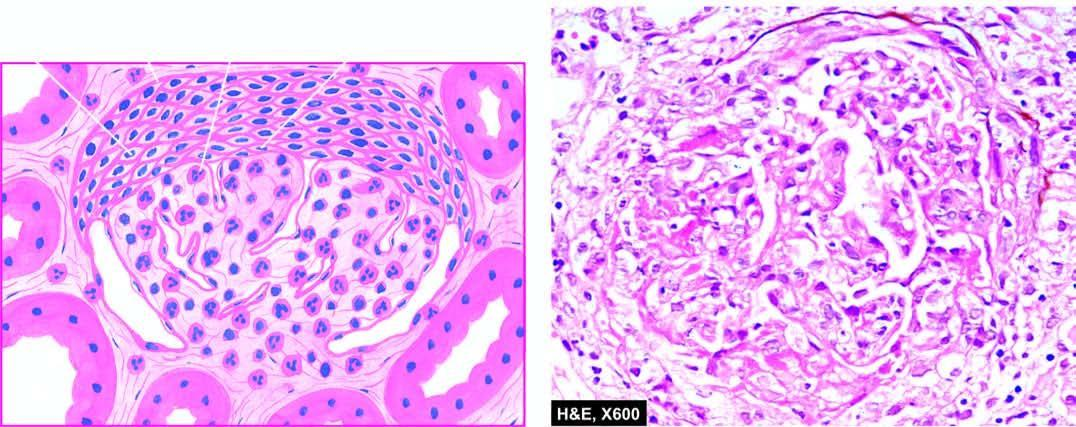what does the tuft show?
Answer the question using a single word or phrase. Hypercellularity and leucocytic infiltration 